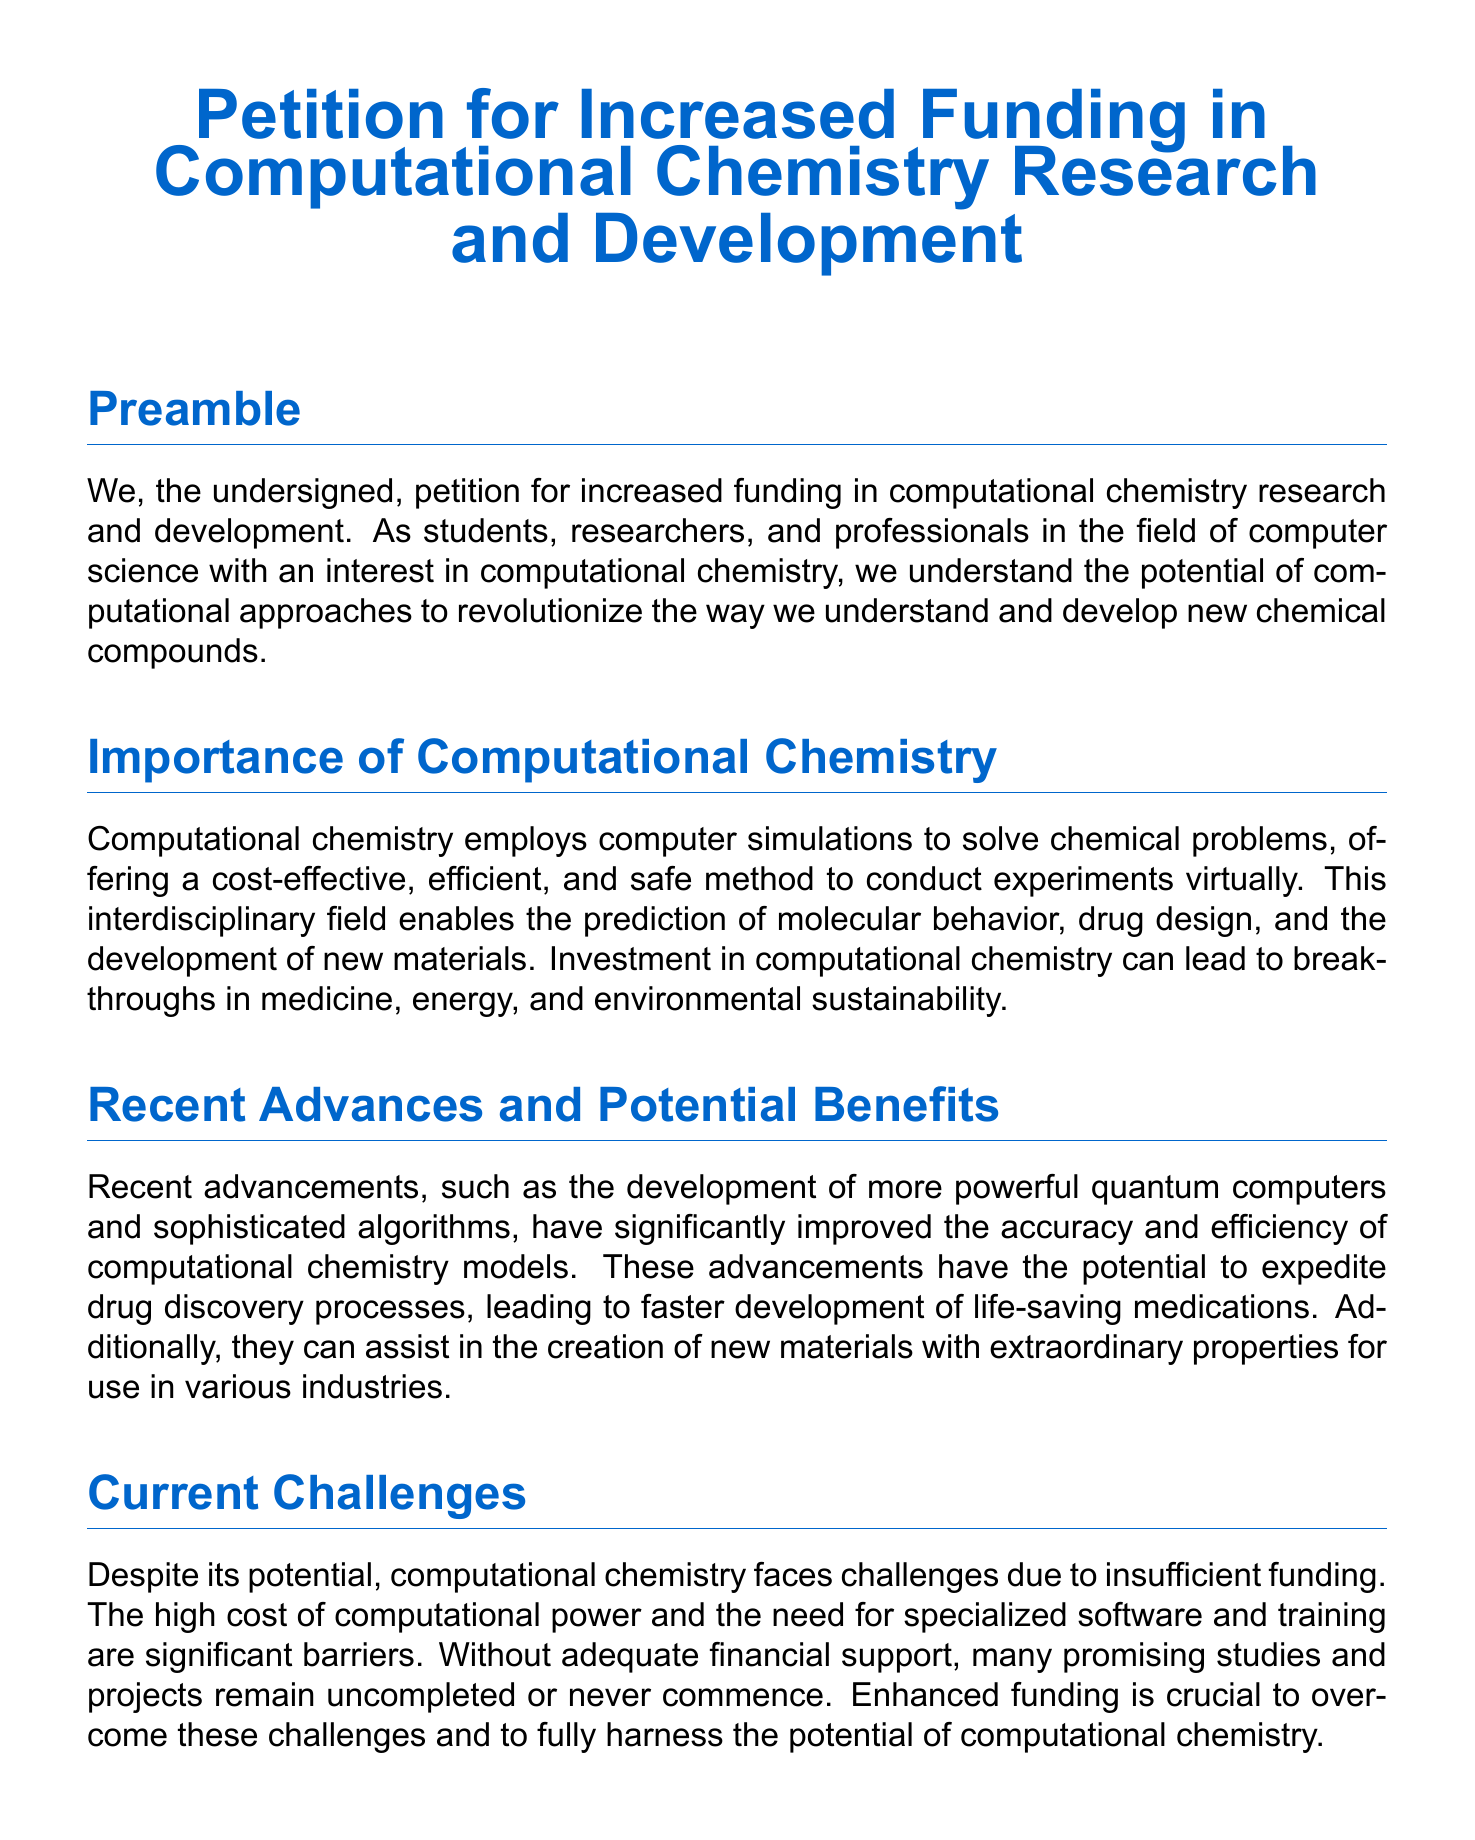What is the title of the petition? The title of the petition is presented at the beginning of the document, highlighting the subject of increased funding in a specific field.
Answer: Petition for Increased Funding in Computational Chemistry Research and Development Who is the petition aimed at? The petition calls upon government bodies, private investors, and educational institutions as part of its call to action.
Answer: Government bodies, private investors, and educational institutions What does computational chemistry allow researchers to do? The document states that computational chemistry enables the prediction of molecular behavior, drug design, and the development of new materials.
Answer: Prediction of molecular behavior, drug design, and development of new materials What is a significant barrier to computational chemistry according to the document? The document mentions the high cost of computational power as a significant barrier in the field of computational chemistry.
Answer: High cost of computational power What recent advancement is highlighted in the petition? The document specifically refers to more powerful quantum computers as a recent advancement that has improved computational chemistry models.
Answer: More powerful quantum computers What does the petition urge signatories to do? The call to action section of the petition emphasizes the necessity for signatories to urge for increased financial support for computational chemistry.
Answer: Urge for increased financial support How is the document structured? The document includes several sections: Preamble, Importance of Computational Chemistry, Recent Advances and Potential Benefits, Current Challenges, and Call to Action.
Answer: Several sections: Preamble, Importance of Computational Chemistry, Recent Advances and Potential Benefits, Current Challenges, and Call to Action What is the color theme of the headings in the document? The document uses a specific shade for its headings, which is depicted through the use of an RGB color code.
Answer: Petition blue 